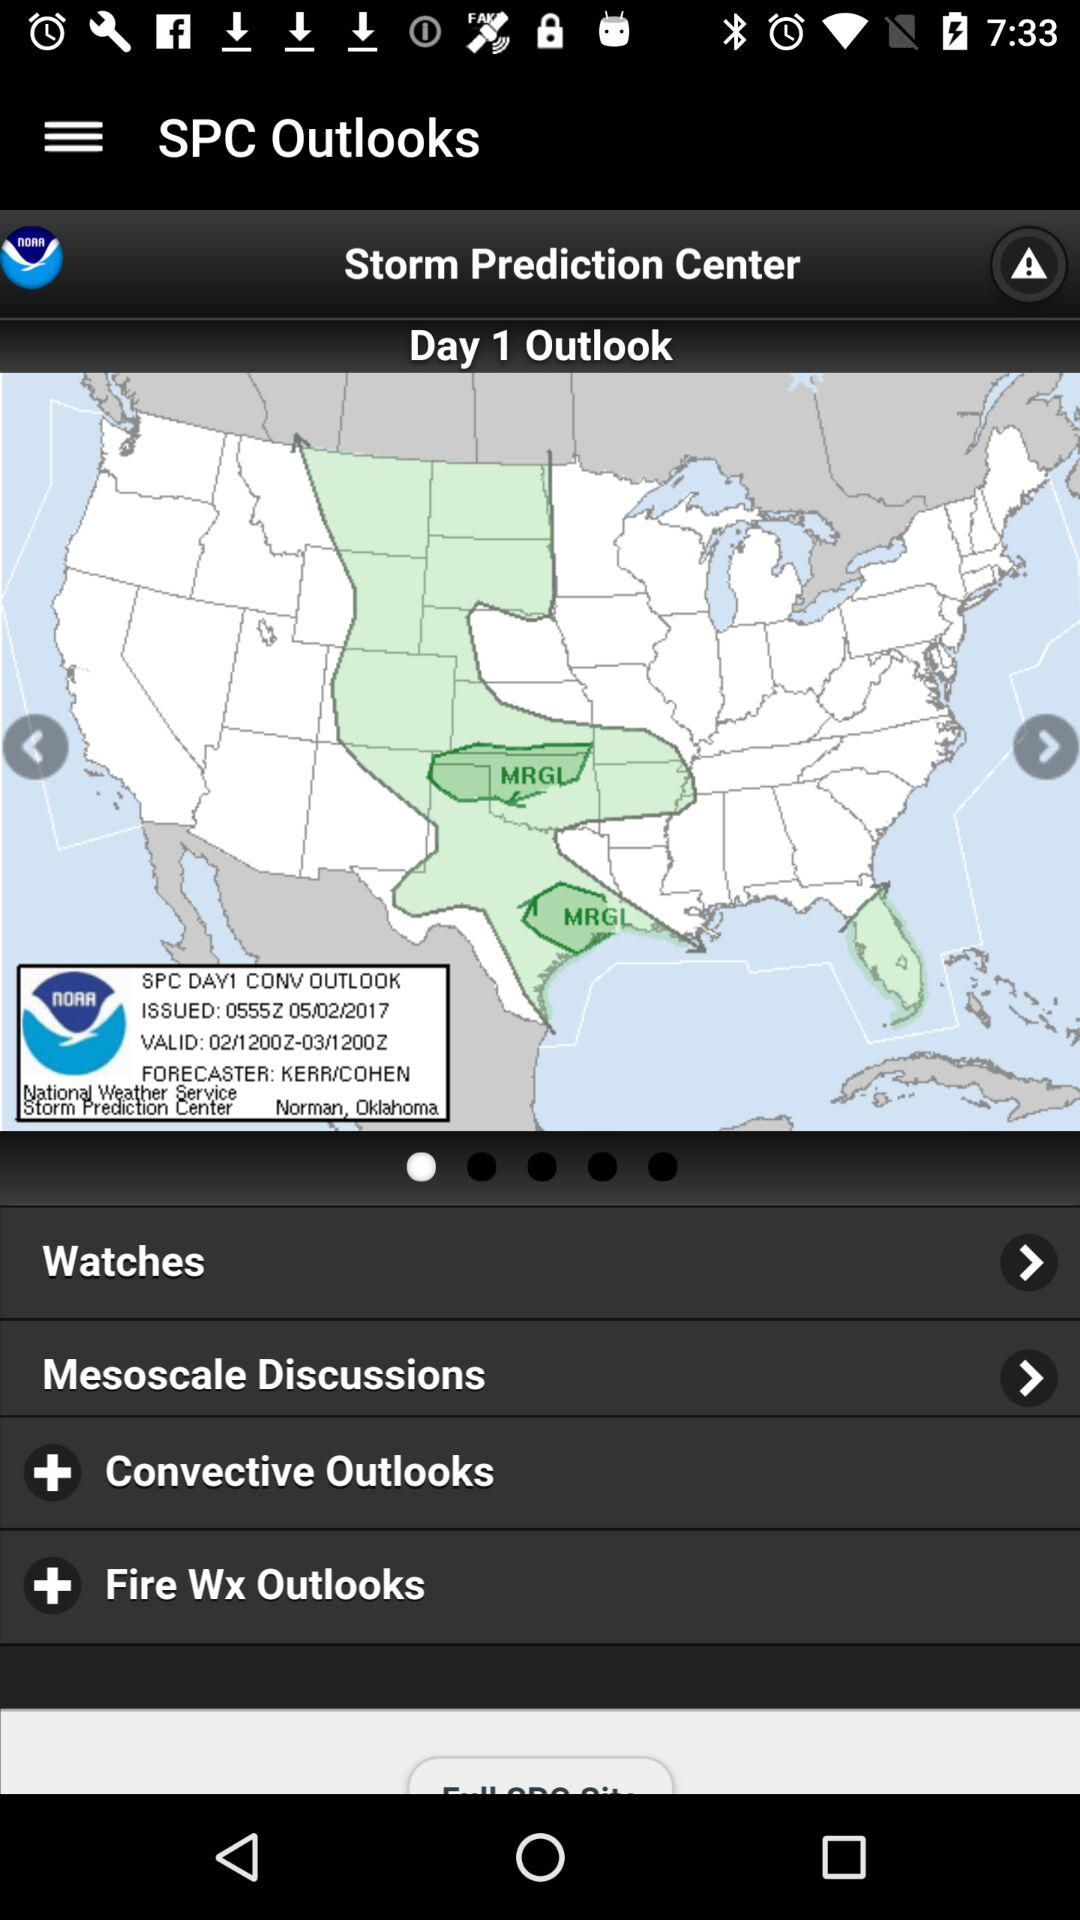Which day's outlook is shown? The outlook is shown for Day 1. 